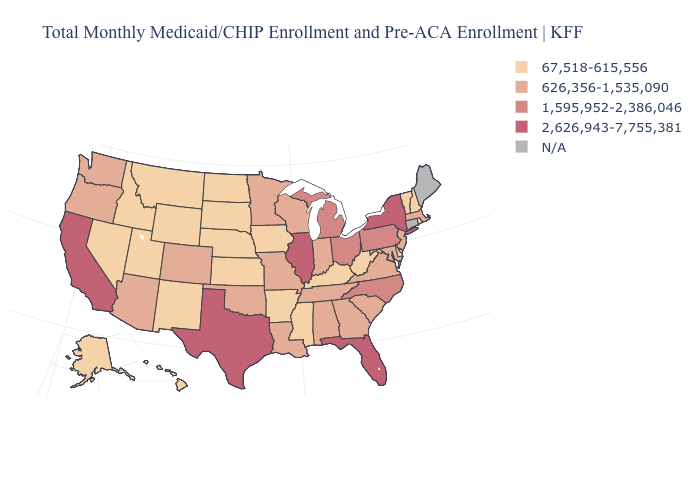Which states have the lowest value in the USA?
Keep it brief. Alaska, Arkansas, Delaware, Hawaii, Idaho, Iowa, Kansas, Kentucky, Mississippi, Montana, Nebraska, Nevada, New Hampshire, New Mexico, North Dakota, Rhode Island, South Dakota, Utah, Vermont, West Virginia, Wyoming. How many symbols are there in the legend?
Answer briefly. 5. Among the states that border South Carolina , which have the highest value?
Short answer required. North Carolina. Among the states that border Nebraska , does Missouri have the highest value?
Answer briefly. Yes. Among the states that border Louisiana , does Texas have the lowest value?
Quick response, please. No. What is the highest value in states that border Virginia?
Answer briefly. 1,595,952-2,386,046. Which states have the lowest value in the MidWest?
Be succinct. Iowa, Kansas, Nebraska, North Dakota, South Dakota. Is the legend a continuous bar?
Give a very brief answer. No. What is the value of California?
Concise answer only. 2,626,943-7,755,381. What is the value of New Jersey?
Keep it brief. 626,356-1,535,090. Name the states that have a value in the range 1,595,952-2,386,046?
Answer briefly. Michigan, North Carolina, Ohio, Pennsylvania. Which states have the lowest value in the USA?
Write a very short answer. Alaska, Arkansas, Delaware, Hawaii, Idaho, Iowa, Kansas, Kentucky, Mississippi, Montana, Nebraska, Nevada, New Hampshire, New Mexico, North Dakota, Rhode Island, South Dakota, Utah, Vermont, West Virginia, Wyoming. Does the first symbol in the legend represent the smallest category?
Write a very short answer. Yes. 